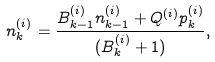<formula> <loc_0><loc_0><loc_500><loc_500>n ^ { ( i ) } _ { k } = \frac { B ^ { ( i ) } _ { k - 1 } n ^ { ( i ) } _ { k - 1 } + Q ^ { ( i ) } p ^ { ( i ) } _ { k } } { ( B ^ { ( i ) } _ { k } + 1 ) } ,</formula> 